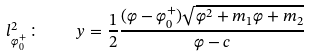<formula> <loc_0><loc_0><loc_500><loc_500>l _ { \varphi _ { 0 } ^ { + } } ^ { 2 } \colon \quad y = \frac { 1 } { 2 } \frac { ( \varphi - \varphi _ { 0 } ^ { + } ) \sqrt { \varphi ^ { 2 } + m _ { 1 } \varphi + m _ { 2 } } } { \varphi - c }</formula> 